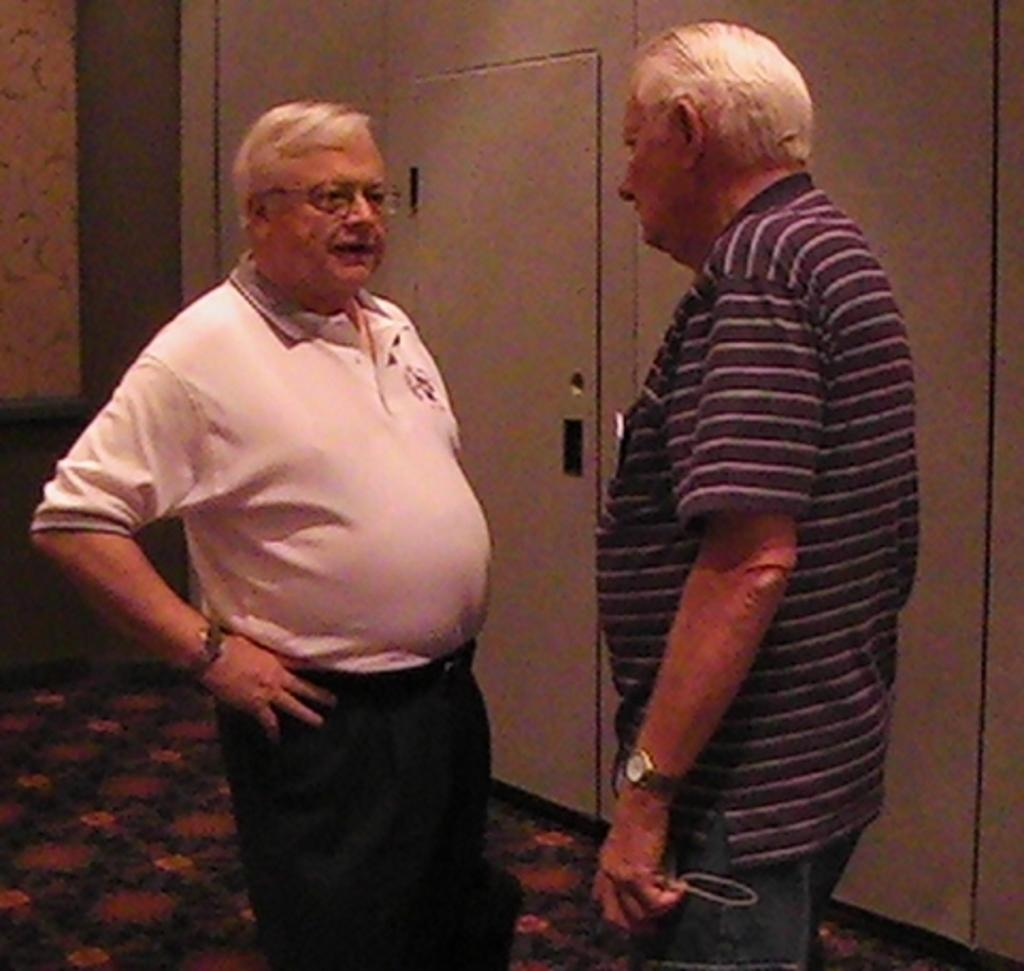How many people are in the image? There are two men in the image. What are the men doing in the image? The men are standing in front. Can you describe the man on the right? The man on the right is holding something. What color is the hydrant next to the men in the image? There is no hydrant present in the image, so we cannot determine its color. 